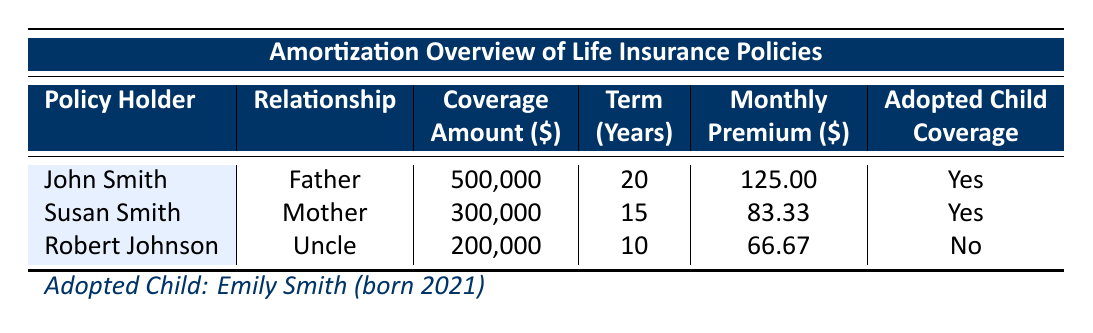What is the total coverage amount provided by John Smith? The table shows that John Smith's life insurance policy has a coverage amount of $500,000. Therefore, the total coverage amount provided by him is simply the value stated in the table.
Answer: 500,000 How much is Susan Smith’s monthly premium? The table indicates that Susan Smith has a monthly premium of $83.33. This value is directly listed in the monthly premium column under her entry.
Answer: 83.33 Is Emily Smith covered under Robert Johnson's life insurance policy? According to the table, Robert Johnson's policy has the "Adopted Child" coverage marked as "No." Therefore, Emily Smith is not covered under this policy.
Answer: No What is the average coverage amount provided by John and Susan Smith combined? John Smith has a coverage amount of $500,000 and Susan Smith has $300,000. To find the average: (500,000 + 300,000) / 2 = 400,000. Hence, the average coverage amount from these two is $400,000.
Answer: 400,000 What is the relationship of Robert Johnson to the adopted child? The table lists Robert Johnson as the "Uncle" of Emily Smith, the adopted child. This is directly stated under the relationship column in the table.
Answer: Uncle What is the total premium paid each month for all three life insurance policies? The monthly premiums shown are $125.00 for John Smith, $83.33 for Susan Smith, and $66.67 for Robert Johnson. Adding these together: 125 + 83.33 + 66.67 = 275.00. Thus, the total monthly premium paid for all policies is $275.00.
Answer: 275.00 Which policy holder has the longest insurance term? John Smith has a term of 20 years, Susan Smith has a term of 15 years, and Robert Johnson has a term of 10 years. John Smith's term is the longest among the three policies.
Answer: John Smith How is the monthly premium of John Smith related to his coverage amount? John Smith pays a monthly premium of $125.00 for a coverage amount of $500,000. To find the relationship, we can observe that the premium represents only a fraction of the coverage—it shows that for every $500,000 coverage, he pays $1,500 annually or $125 monthly. It's a standard ratio that shows how premiums correspond to coverage amounts in life insurance.
Answer: 125.00 per 500,000 